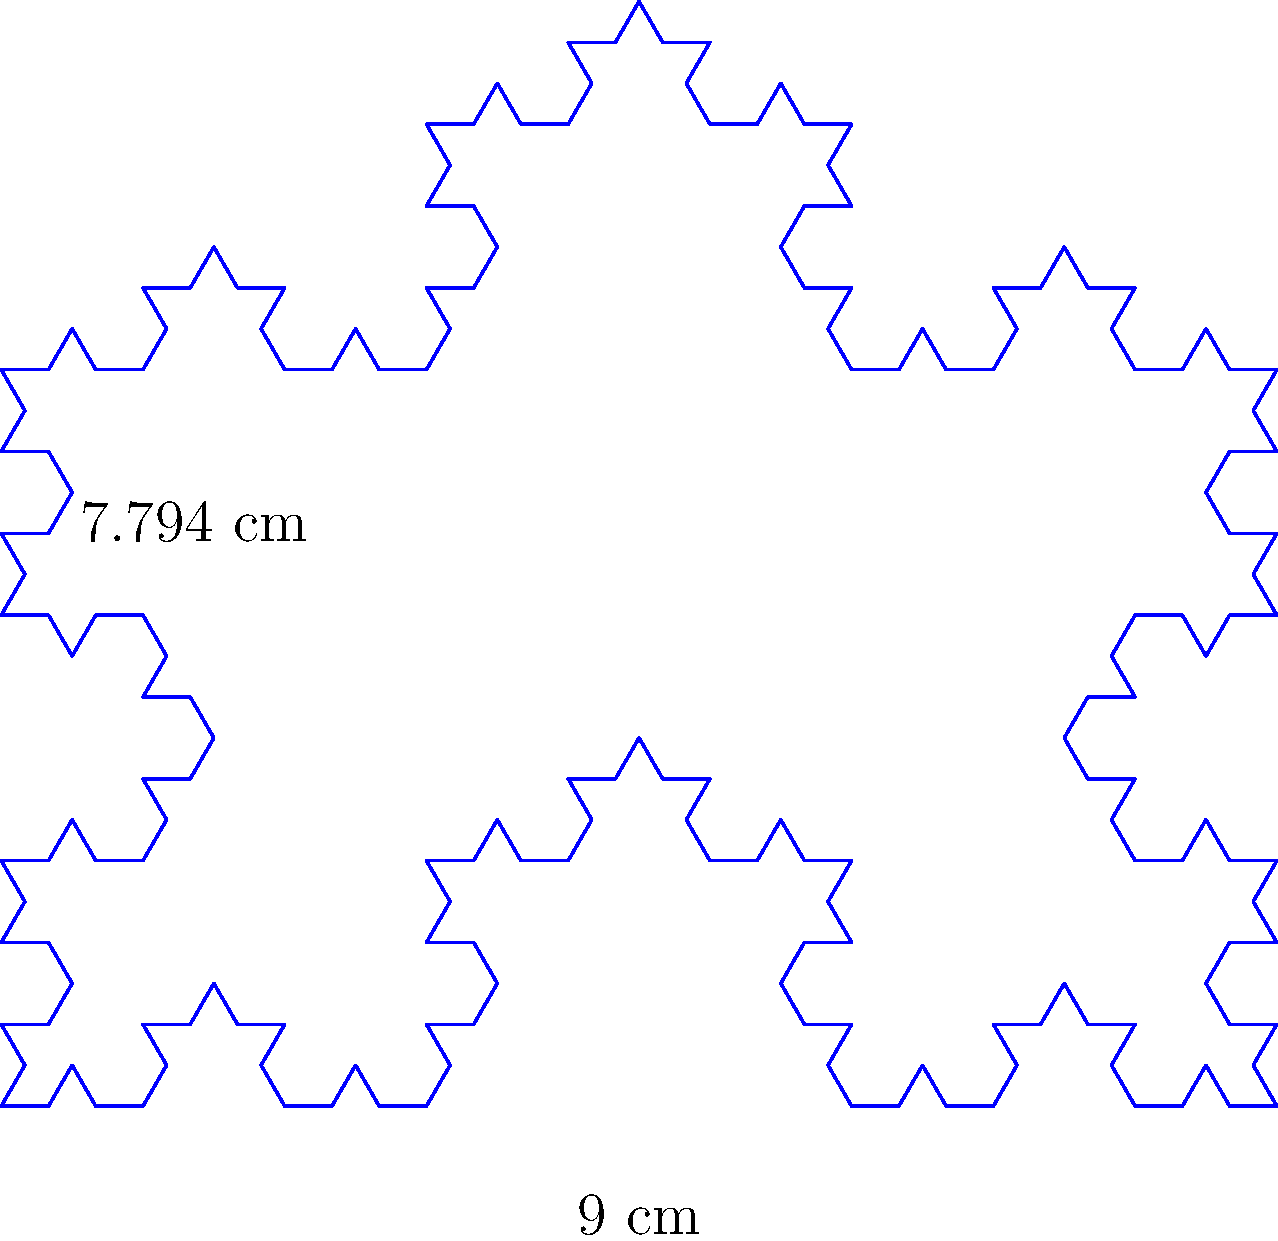You are designing a dress with a fractal-inspired triangular pattern based on the Koch snowflake. The base of the triangle is 9 cm, and its height is 7.794 cm. If you were to fill the entire area of this triangular pattern with a print, what would be the approximate area (in square centimeters) of the print needed? To solve this problem, we need to follow these steps:

1) The shape we're dealing with is a triangle. The formula for the area of a triangle is:

   $$ A = \frac{1}{2} \times base \times height $$

2) We are given:
   - Base = 9 cm
   - Height = 7.794 cm

3) Let's substitute these values into our formula:

   $$ A = \frac{1}{2} \times 9 \times 7.794 $$

4) Now, let's calculate:

   $$ A = 4.5 \times 7.794 = 35.073 \text{ cm}^2 $$

5) Rounding to two decimal places:

   $$ A \approx 35.07 \text{ cm}^2 $$

Therefore, you would need approximately 35.07 square centimeters of print to fill the triangular pattern.
Answer: 35.07 cm² 